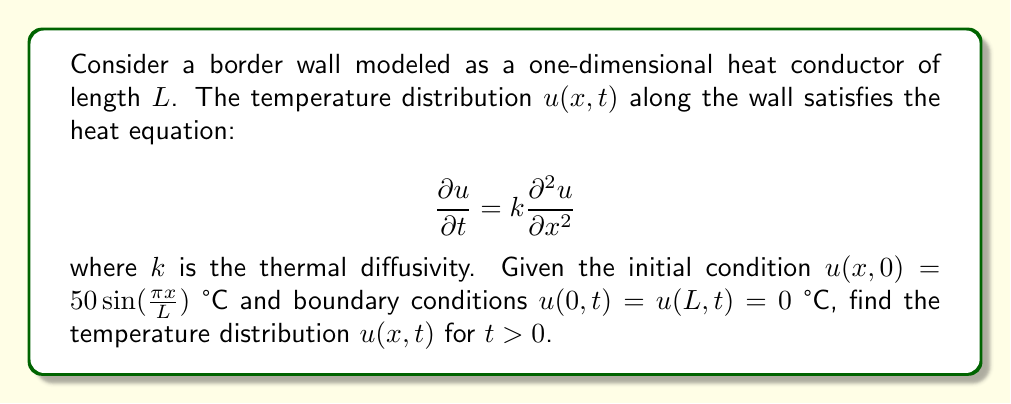Help me with this question. To solve this heat equation, we'll use the method of separation of variables:

1) Assume $u(x,t) = X(x)T(t)$

2) Substituting into the heat equation:
   $$X(x)T'(t) = kX''(x)T(t)$$

3) Dividing by $X(x)T(t)$:
   $$\frac{T'(t)}{T(t)} = k\frac{X''(x)}{X(x)} = -\lambda$$

4) This gives us two ODEs:
   $$T'(t) + \lambda kT(t) = 0$$
   $$X''(x) + \lambda X(x) = 0$$

5) The boundary conditions imply $X(0) = X(L) = 0$, which gives the eigenvalue problem:
   $$\lambda_n = (\frac{n\pi}{L})^2, \quad X_n(x) = \sin(\frac{n\pi x}{L})$$

6) The general solution is:
   $$u(x,t) = \sum_{n=1}^{\infty} A_n\sin(\frac{n\pi x}{L})e^{-k(\frac{n\pi}{L})^2t}$$

7) Using the initial condition:
   $$50\sin(\frac{\pi x}{L}) = \sum_{n=1}^{\infty} A_n\sin(\frac{n\pi x}{L})$$

8) This implies $A_1 = 50$ and $A_n = 0$ for $n > 1$

Therefore, the final solution is:
$$u(x,t) = 50\sin(\frac{\pi x}{L})e^{-k(\frac{\pi}{L})^2t}$$
Answer: $u(x,t) = 50\sin(\frac{\pi x}{L})e^{-k(\frac{\pi}{L})^2t}$ 